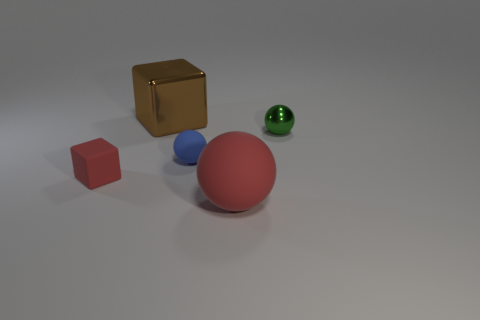What material is the red object in front of the red object to the left of the blue matte ball made of? While I cannot confirm the exact material of the red object, based on its appearance and the matte texture, it could be a representation of a rubber or plastic material. 